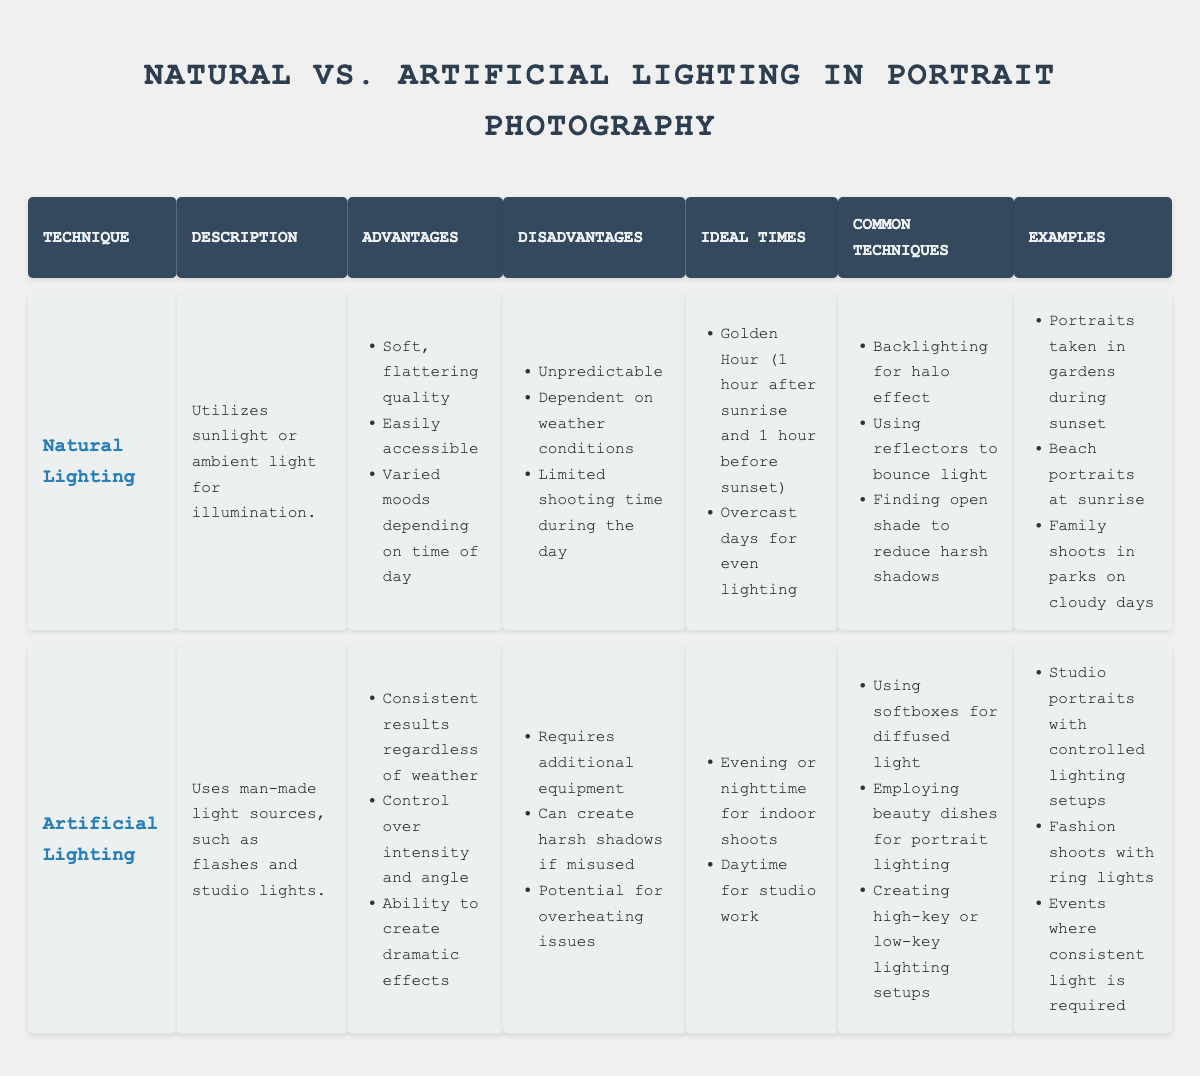What are two advantages of using natural lighting? The advantages of natural lighting can be found in the "Advantages" section of the table. They include the soft, flattering quality of the light and its accessibility.
Answer: Soft quality, accessible Is it true that artificial lighting requires additional equipment? Looking at the "Disadvantages" for artificial lighting, one of the listed drawbacks is that it requires additional equipment.
Answer: Yes What is an ideal time to use natural lighting? The "Ideal Times" section for natural lighting lists "Golden Hour" (1 hour after sunrise and 1 hour before sunset) as one of the best times to utilize it.
Answer: Golden Hour What are three common techniques used in artificial lighting? The "Common Techniques" section for artificial lighting lists three techniques: using softboxes for diffused light, employing beauty dishes for portrait lighting, and creating high-key or low-key setups.
Answer: Softboxes, beauty dishes, high-key/low-key setups Which lighting technique provides consistent results regardless of weather conditions? Referring to the advantages of each technique, artificial lighting is noted for providing consistent results regardless of weather.
Answer: Artificial lighting How many disadvantages are listed for natural lighting? In the "Disadvantages" section for natural lighting, there are three negative points outlined: unpredictability, dependence on weather, and limited shooting time.
Answer: Three disadvantages Which technique is best for creating dramatic effects? The advantages of artificial lighting state it allows for the creation of dramatic effects, making it the best choice for such purposes.
Answer: Artificial lighting If you want to shoot portraits in the evening, which lighting technique should you use? The "Ideal Times" section under artificial lighting specifies that evening or nighttime is suitable for indoor shoots, indicating that artificial lighting should be used.
Answer: Artificial lighting What examples are provided for portraits using natural lighting? The "Examples" section for natural lighting includes portraits taken in gardens during sunset, beach portraits at sunrise, and family shoots in parks on cloudy days.
Answer: Gardens at sunset, beach at sunrise, parks on cloudy days What is the difference in ideal times for natural and artificial lighting techniques? The table lists "Golden Hour and overcast days" for natural lighting and "evening, nighttime, and daytime for studio work" for artificial lighting, highlighting that natural lighting is dependent on the time of day and weather, whereas artificial lighting can be used at various times.
Answer: Natural: Golden Hour; Artificial: Evening, daytime 